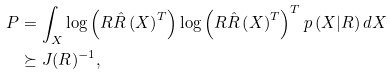<formula> <loc_0><loc_0><loc_500><loc_500>P & = \int _ { X } \log \left ( R \hat { R } \left ( X \right ) ^ { T } \right ) \log \left ( R \hat { R } \left ( X \right ) ^ { T } \right ) ^ { T } p \left ( X | R \right ) d X \\ & \succeq J ( R ) ^ { - 1 } ,</formula> 